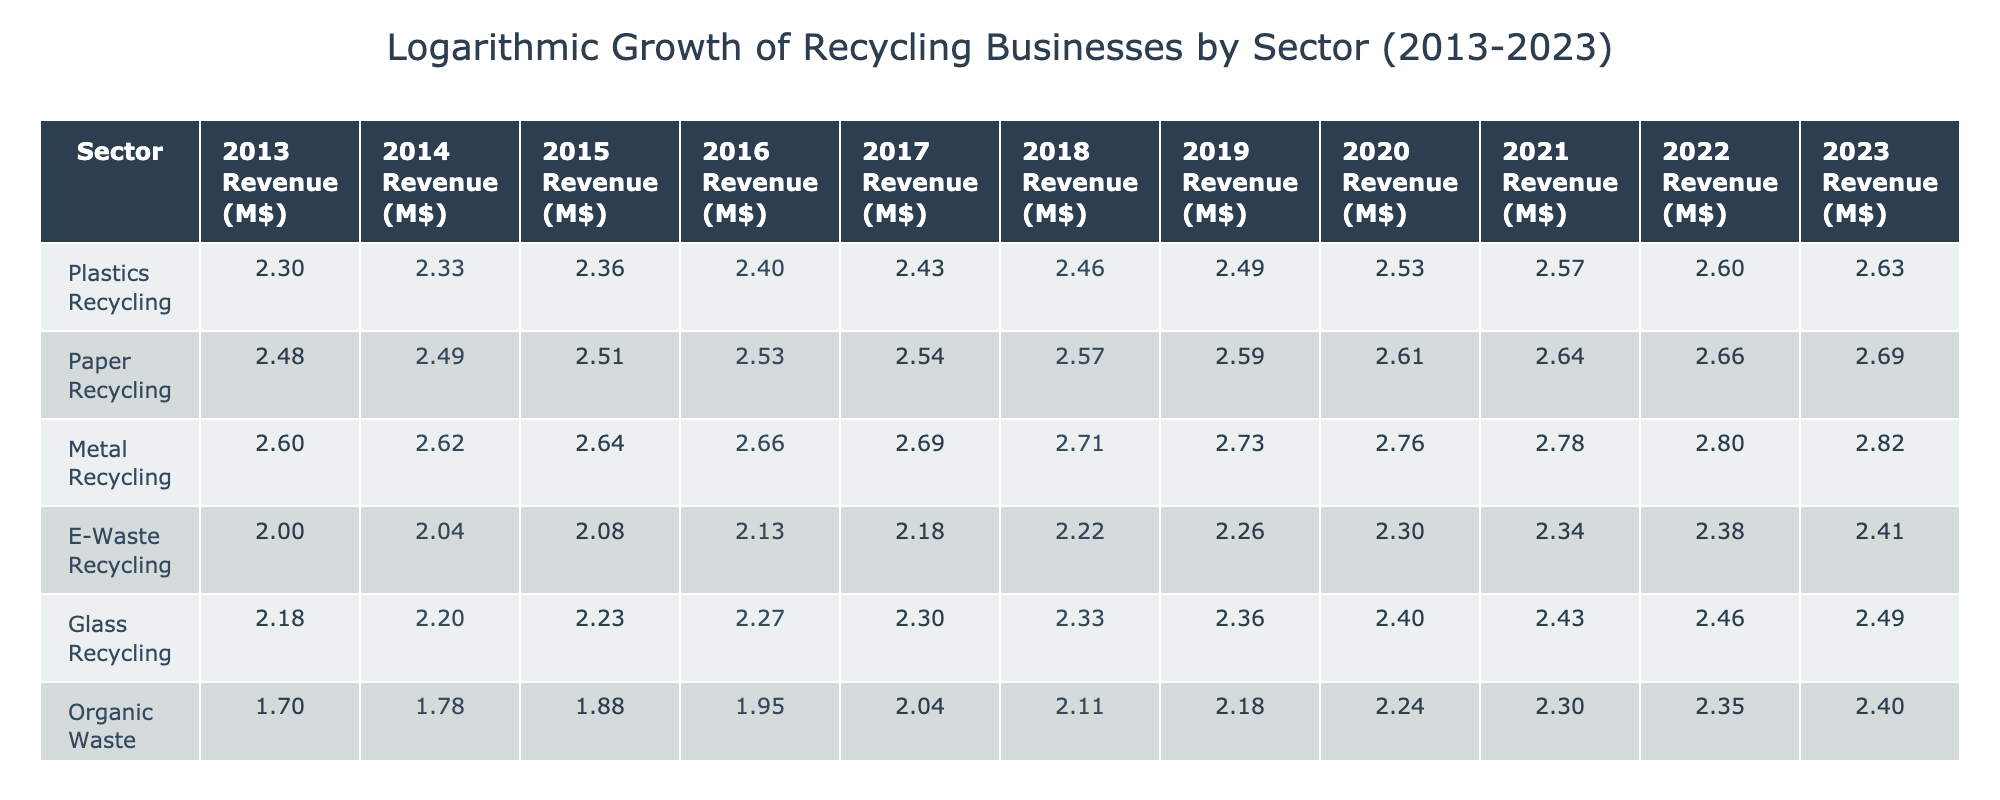What was the revenue from Plastic Recycling in 2022? The table shows that the revenue for Plastic Recycling in 2022 is listed directly under the corresponding year column, which is 400 million dollars.
Answer: 400 What is the percentage increase in revenue for Paper Recycling from 2013 to 2023? The revenue for Paper Recycling in 2013 was 300 million dollars and in 2023 it was 490 million dollars. The increase is 490 - 300 = 190 million dollars. To find the percentage increase, divide by the original value: (190 / 300) * 100 = 63.33%.
Answer: 63.33 Is the revenue for E-Waste Recycling higher in 2023 than for Textile Recycling in 2022? The revenue for E-Waste Recycling in 2023 is 260 million dollars, and for Textile Recycling in 2022 it is 175 million dollars. Since 260 is greater than 175, the statement is true.
Answer: Yes Which sector had the highest revenue in 2021, and what was that revenue? By examining the 2021 revenue column, we find Metal Recycling had the highest figure at 600 million dollars, compared to other sectors.
Answer: Metal Recycling, 600 What is the total revenue for Organic Waste Recycling over the entire decade from 2013 to 2023? The revenue for Organic Waste Recycling for each year is summed as follows: 50 + 60 + 75 + 90 + 110 + 130 + 150 + 175 + 200 + 225 = 1,120 million dollars.
Answer: 1,120 What was the compound annual growth rate (CAGR) for Glass Recycling from 2013 to 2023? The revenue in 2013 was 150 million dollars and in 2023 it is 310 million dollars. The CAGR is calculated by [(Final Value / Initial Value) ^ (1 / Number of Years)] - 1: [(310 / 150) ^ (1 / 10)] - 1 = approximately 0.0784 or 7.84%.
Answer: 7.84% Did Metal Recycling consistently increase in revenue every year from 2013 to 2023? By reviewing the revenues listed from 2013 to 2023 for Metal Recycling, we see that all values show an increase, confirming the statement is true.
Answer: Yes Which sector experienced the least revenue growth in percentage terms over the decade? Calculating the percentage growth for each sector, we find Organic Waste Recycling had the least growth: from 50 to 250 million dollars, an increase of 400%, which is the lowest relative to others with higher growth percentages.
Answer: Organic Waste Recycling What was the revenue of Textile Recycling in 2016, and how does it compare to the revenue from E-Waste Recycling in the same year? The revenue for Textile Recycling in 2016 was 95 million dollars, while E-Waste Recycling's revenue for the same year was 135 million dollars. This shows that E-Waste Recycling had a higher revenue than Textile Recycling.
Answer: E-Waste Recycling higher 